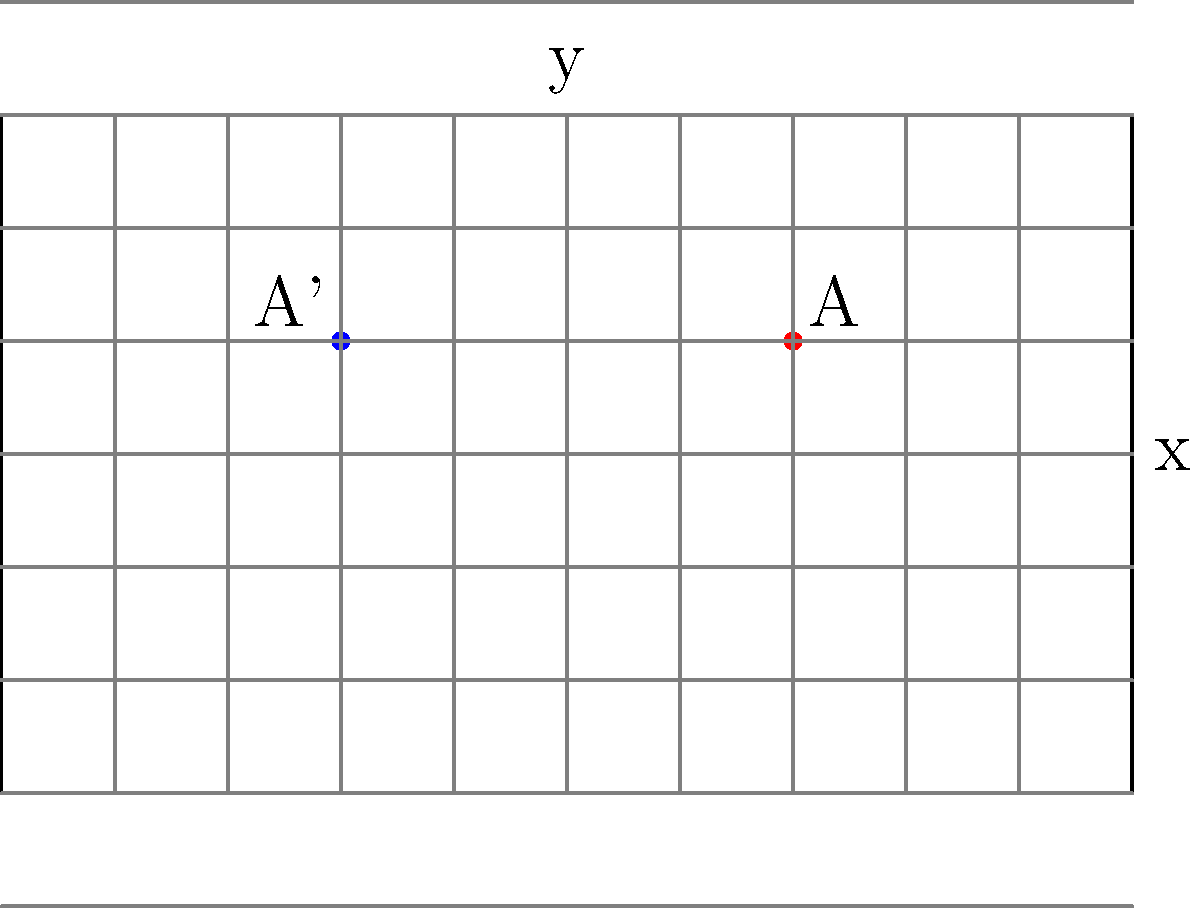As a midfielder, you're positioned at point A(2,1) on the soccer field. If your position is reflected across the halfway line (represented by the y-axis), what are the coordinates of your new position A'? Express your answer as an ordered pair. To solve this problem, we need to understand the concept of reflection across the y-axis:

1. In a reflection across the y-axis, the y-coordinate remains unchanged.
2. The x-coordinate changes sign (positive becomes negative and vice versa).

Given:
- Initial position: A(2,1)
- Reflection across the y-axis (halfway line)

Step 1: Keep the y-coordinate the same.
- y-coordinate of A' = 1

Step 2: Change the sign of the x-coordinate.
- x-coordinate of A = 2
- x-coordinate of A' = -2

Step 3: Combine the new x and y coordinates to form the reflected position.
- A' = (-2, 1)

Therefore, the reflected position of the player across the halfway line is (-2, 1).
Answer: $(-2, 1)$ 